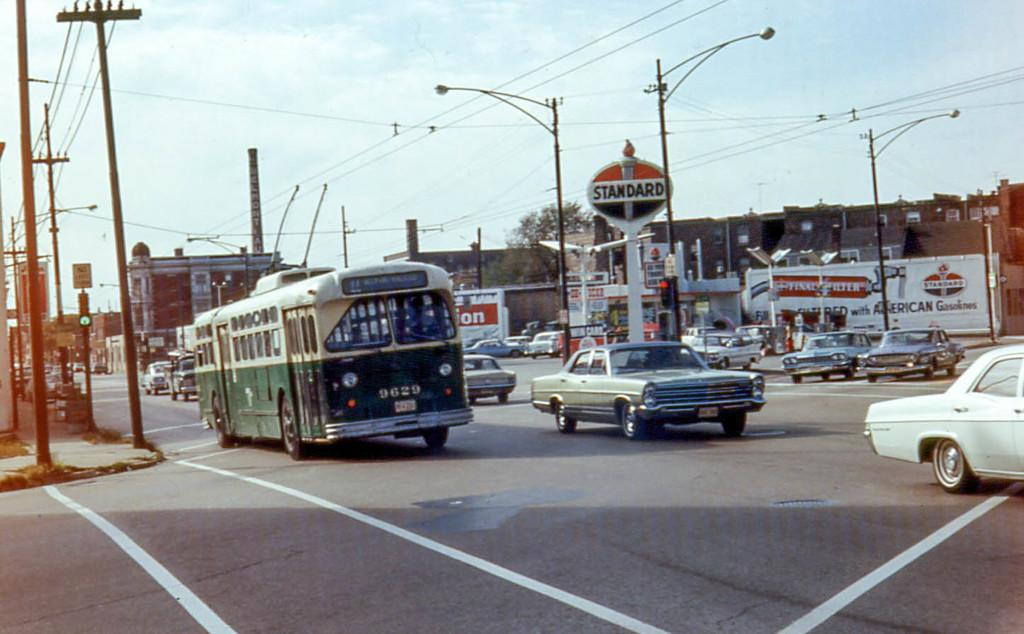Provide a one-sentence caption for the provided image. A roadway with a green bus and lots of cars in front of a Standard gas station. 